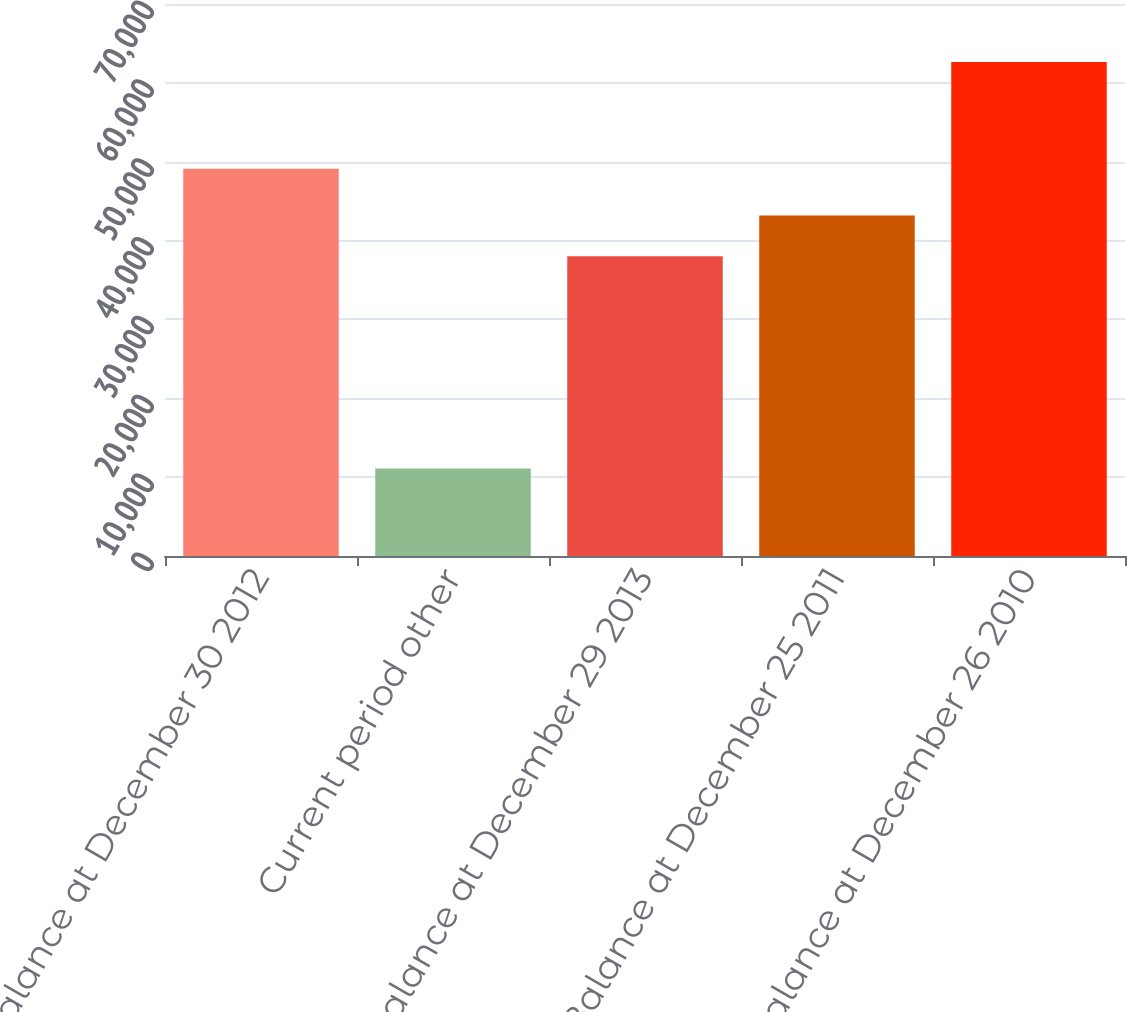<chart> <loc_0><loc_0><loc_500><loc_500><bar_chart><fcel>Balance at December 30 2012<fcel>Current period other<fcel>Balance at December 29 2013<fcel>Balance at December 25 2011<fcel>Balance at December 26 2010<nl><fcel>49123<fcel>11104<fcel>38019<fcel>43172.8<fcel>62642<nl></chart> 